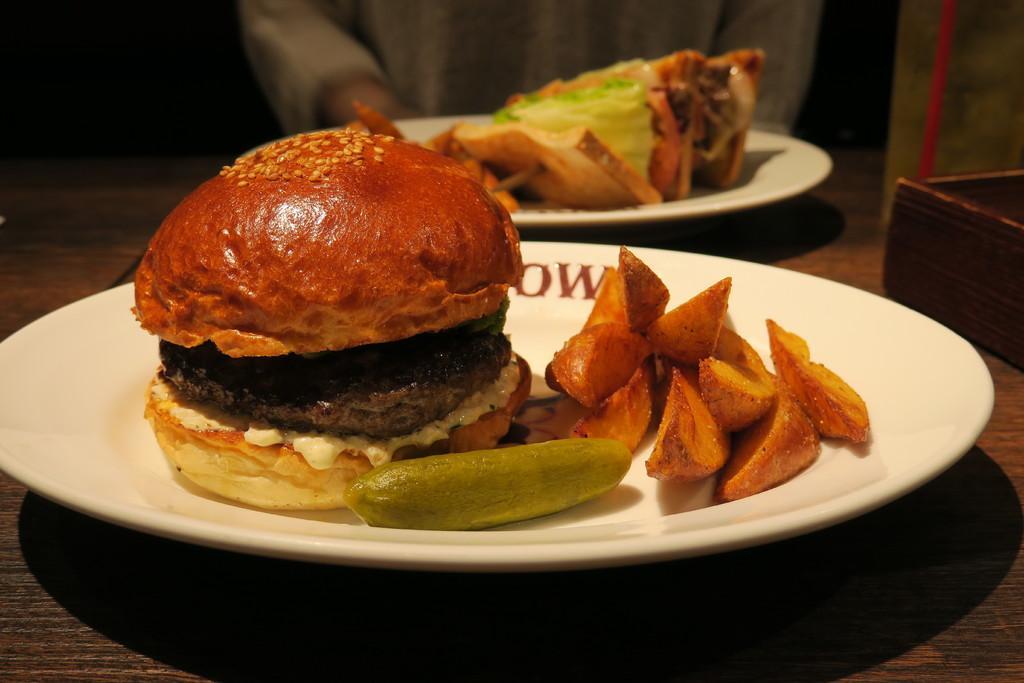Could you give a brief overview of what you see in this image? In this image we can see two plates with food on the table, some text on the plate, some objects on the table, in the background it looks like a person truncated at the top of the image and the background is dark. 